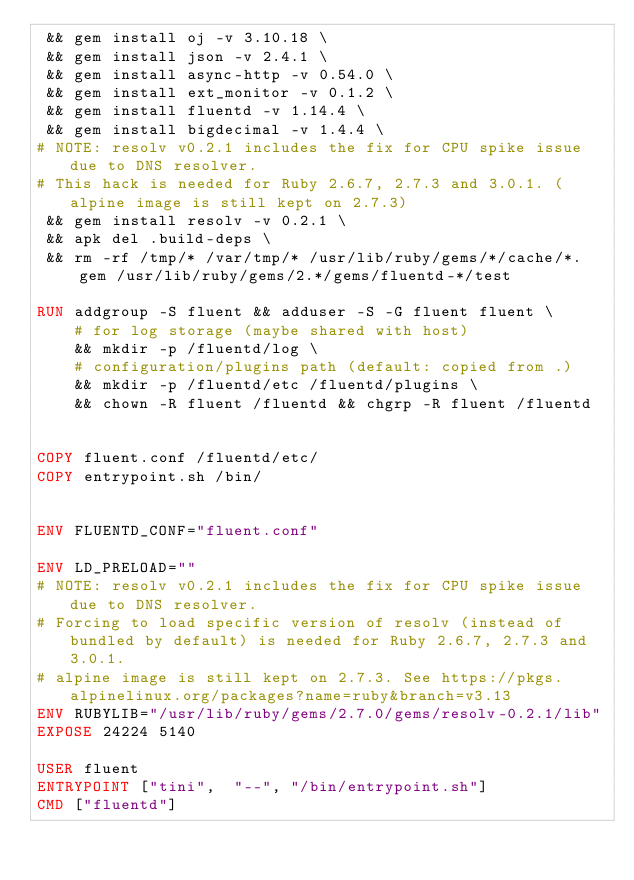Convert code to text. <code><loc_0><loc_0><loc_500><loc_500><_Dockerfile_> && gem install oj -v 3.10.18 \
 && gem install json -v 2.4.1 \
 && gem install async-http -v 0.54.0 \
 && gem install ext_monitor -v 0.1.2 \
 && gem install fluentd -v 1.14.4 \
 && gem install bigdecimal -v 1.4.4 \
# NOTE: resolv v0.2.1 includes the fix for CPU spike issue due to DNS resolver.
# This hack is needed for Ruby 2.6.7, 2.7.3 and 3.0.1. (alpine image is still kept on 2.7.3)
 && gem install resolv -v 0.2.1 \
 && apk del .build-deps \
 && rm -rf /tmp/* /var/tmp/* /usr/lib/ruby/gems/*/cache/*.gem /usr/lib/ruby/gems/2.*/gems/fluentd-*/test

RUN addgroup -S fluent && adduser -S -G fluent fluent \
    # for log storage (maybe shared with host)
    && mkdir -p /fluentd/log \
    # configuration/plugins path (default: copied from .)
    && mkdir -p /fluentd/etc /fluentd/plugins \
    && chown -R fluent /fluentd && chgrp -R fluent /fluentd


COPY fluent.conf /fluentd/etc/
COPY entrypoint.sh /bin/


ENV FLUENTD_CONF="fluent.conf"

ENV LD_PRELOAD=""
# NOTE: resolv v0.2.1 includes the fix for CPU spike issue due to DNS resolver.
# Forcing to load specific version of resolv (instead of bundled by default) is needed for Ruby 2.6.7, 2.7.3 and 3.0.1.
# alpine image is still kept on 2.7.3. See https://pkgs.alpinelinux.org/packages?name=ruby&branch=v3.13
ENV RUBYLIB="/usr/lib/ruby/gems/2.7.0/gems/resolv-0.2.1/lib"
EXPOSE 24224 5140

USER fluent
ENTRYPOINT ["tini",  "--", "/bin/entrypoint.sh"]
CMD ["fluentd"]

</code> 